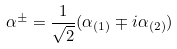Convert formula to latex. <formula><loc_0><loc_0><loc_500><loc_500>\alpha ^ { \pm } = \frac { 1 } { \sqrt { 2 } } ( \alpha _ { ( 1 ) } \mp i \alpha _ { ( 2 ) } )</formula> 